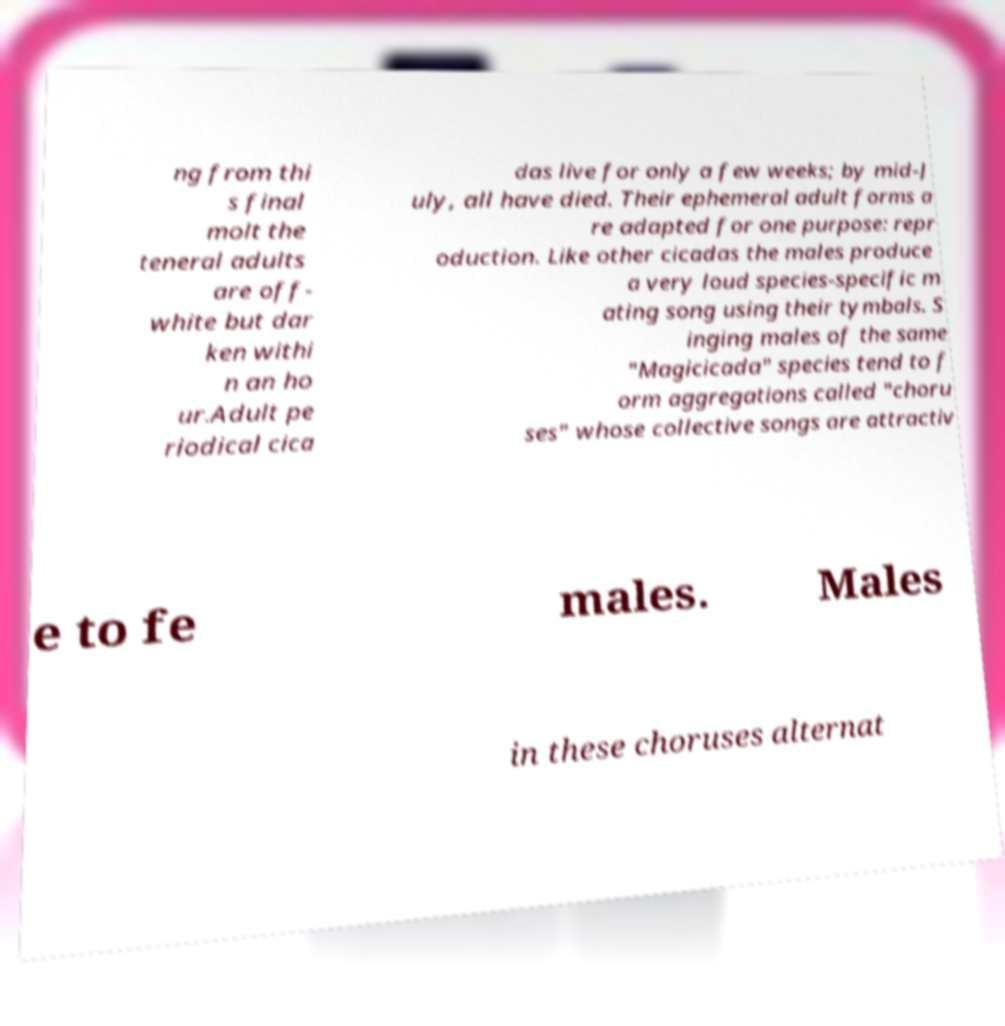There's text embedded in this image that I need extracted. Can you transcribe it verbatim? ng from thi s final molt the teneral adults are off- white but dar ken withi n an ho ur.Adult pe riodical cica das live for only a few weeks; by mid-J uly, all have died. Their ephemeral adult forms a re adapted for one purpose: repr oduction. Like other cicadas the males produce a very loud species-specific m ating song using their tymbals. S inging males of the same "Magicicada" species tend to f orm aggregations called "choru ses" whose collective songs are attractiv e to fe males. Males in these choruses alternat 